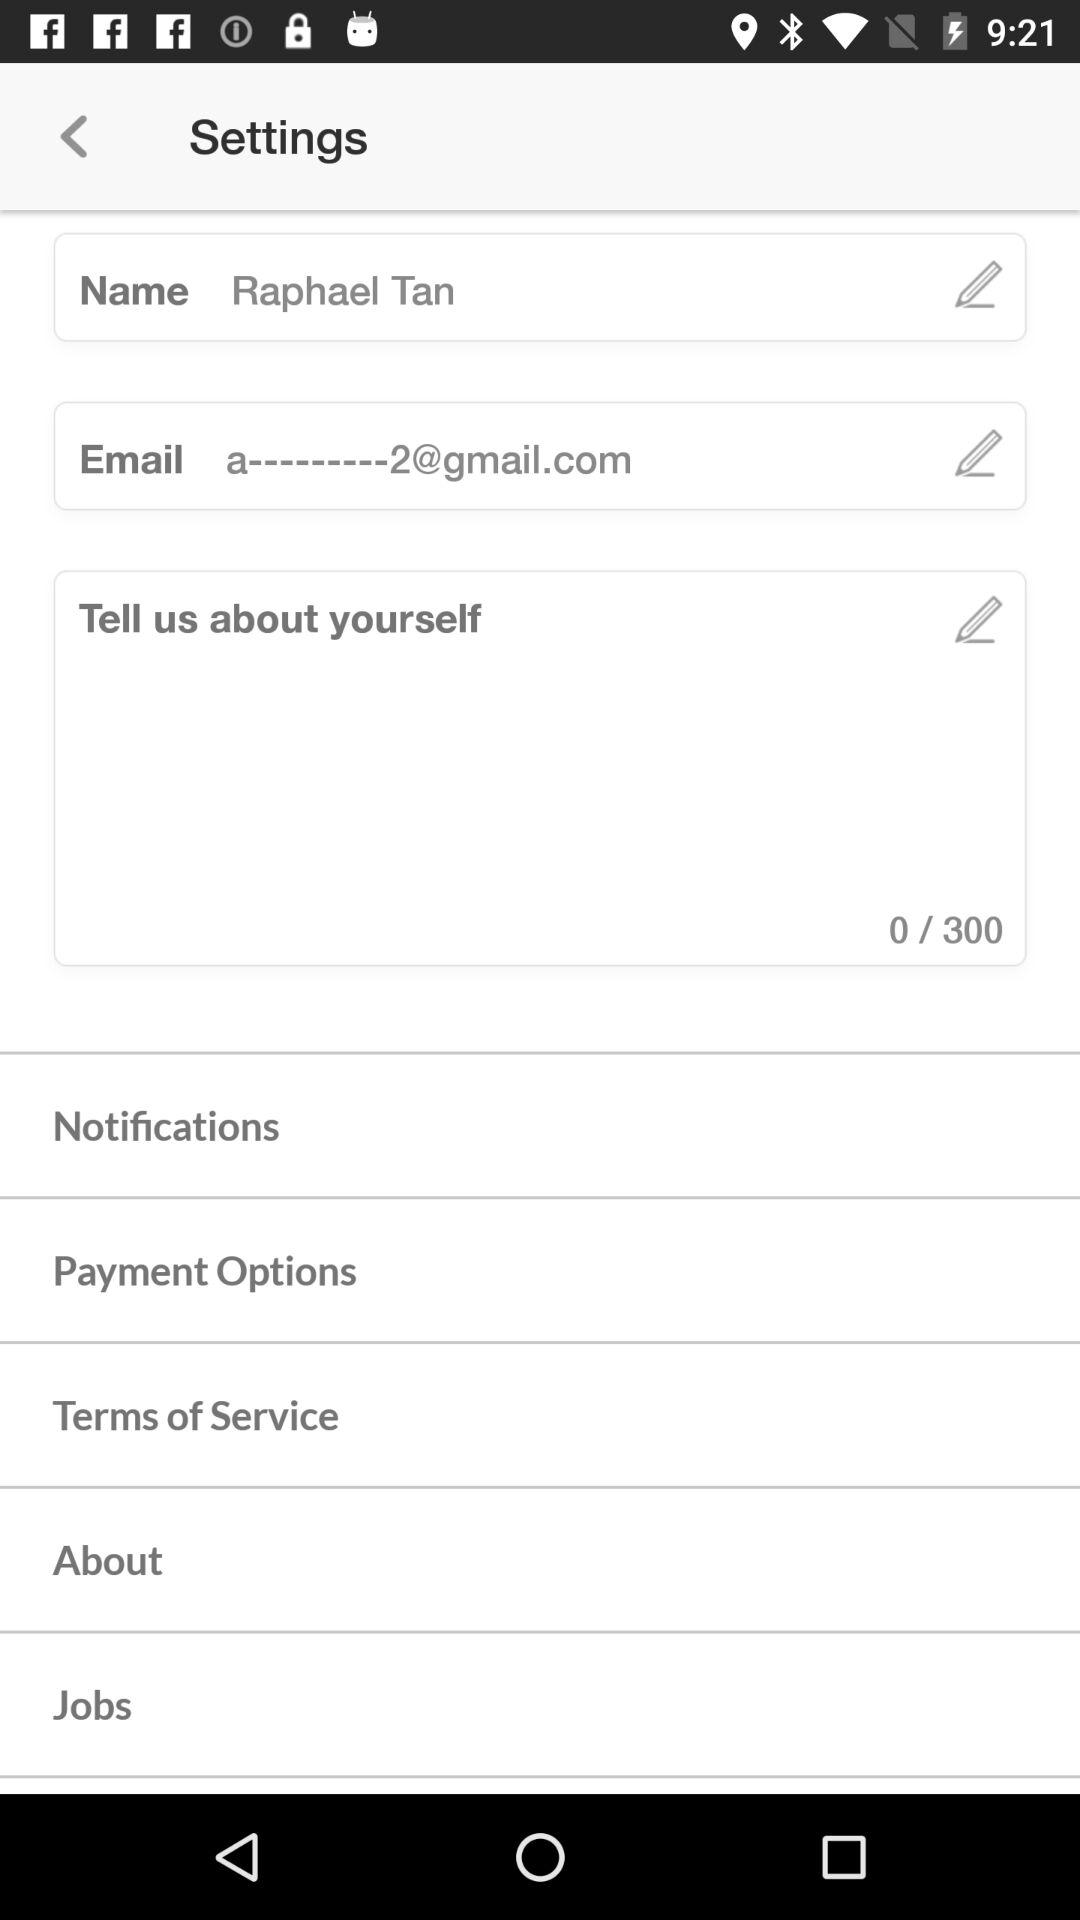How many maximum characters can we write in the "Tell us about yourself" field? You can write a maximum of 300 characters. 